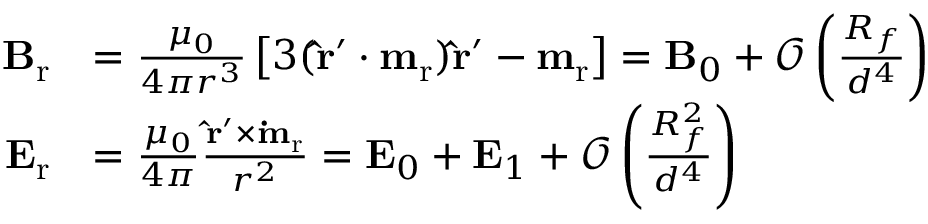Convert formula to latex. <formula><loc_0><loc_0><loc_500><loc_500>\begin{array} { r l } { B _ { r } } & { = \frac { \mu _ { 0 } } { 4 \pi r ^ { 3 } } \left [ 3 ( \hat { r } ^ { \prime } \cdot m _ { r } ) \hat { r } ^ { \prime } - m _ { r } \right ] = B _ { 0 } + \mathcal { O } \left ( \frac { R _ { f } } { d ^ { 4 } } \right ) } \\ { E _ { r } } & { = \frac { \mu _ { 0 } } { 4 \pi } \frac { \hat { r } ^ { \prime } \times \dot { m } _ { r } } { r ^ { 2 } } = E _ { 0 } + E _ { 1 } + \mathcal { O } \left ( \frac { R _ { f } ^ { 2 } } { d ^ { 4 } } \right ) } \end{array}</formula> 